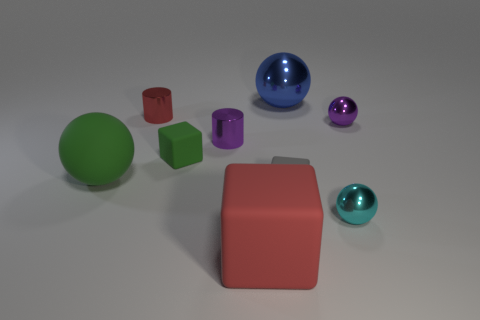What material is the thing that is the same color as the matte sphere?
Your response must be concise. Rubber. What number of metallic things are either purple cylinders or cyan things?
Provide a succinct answer. 2. Do the green matte cube and the green ball have the same size?
Ensure brevity in your answer.  No. Are there fewer cyan shiny objects behind the green matte sphere than small cyan objects that are behind the red metallic cylinder?
Your response must be concise. No. Is there any other thing that is the same size as the purple cylinder?
Offer a terse response. Yes. How big is the green cube?
Make the answer very short. Small. How many large objects are either gray shiny things or gray matte things?
Provide a short and direct response. 0. Does the blue metal object have the same size as the purple shiny object left of the blue object?
Offer a terse response. No. Is there anything else that is the same shape as the blue shiny object?
Your answer should be very brief. Yes. How many matte things are there?
Give a very brief answer. 4. 